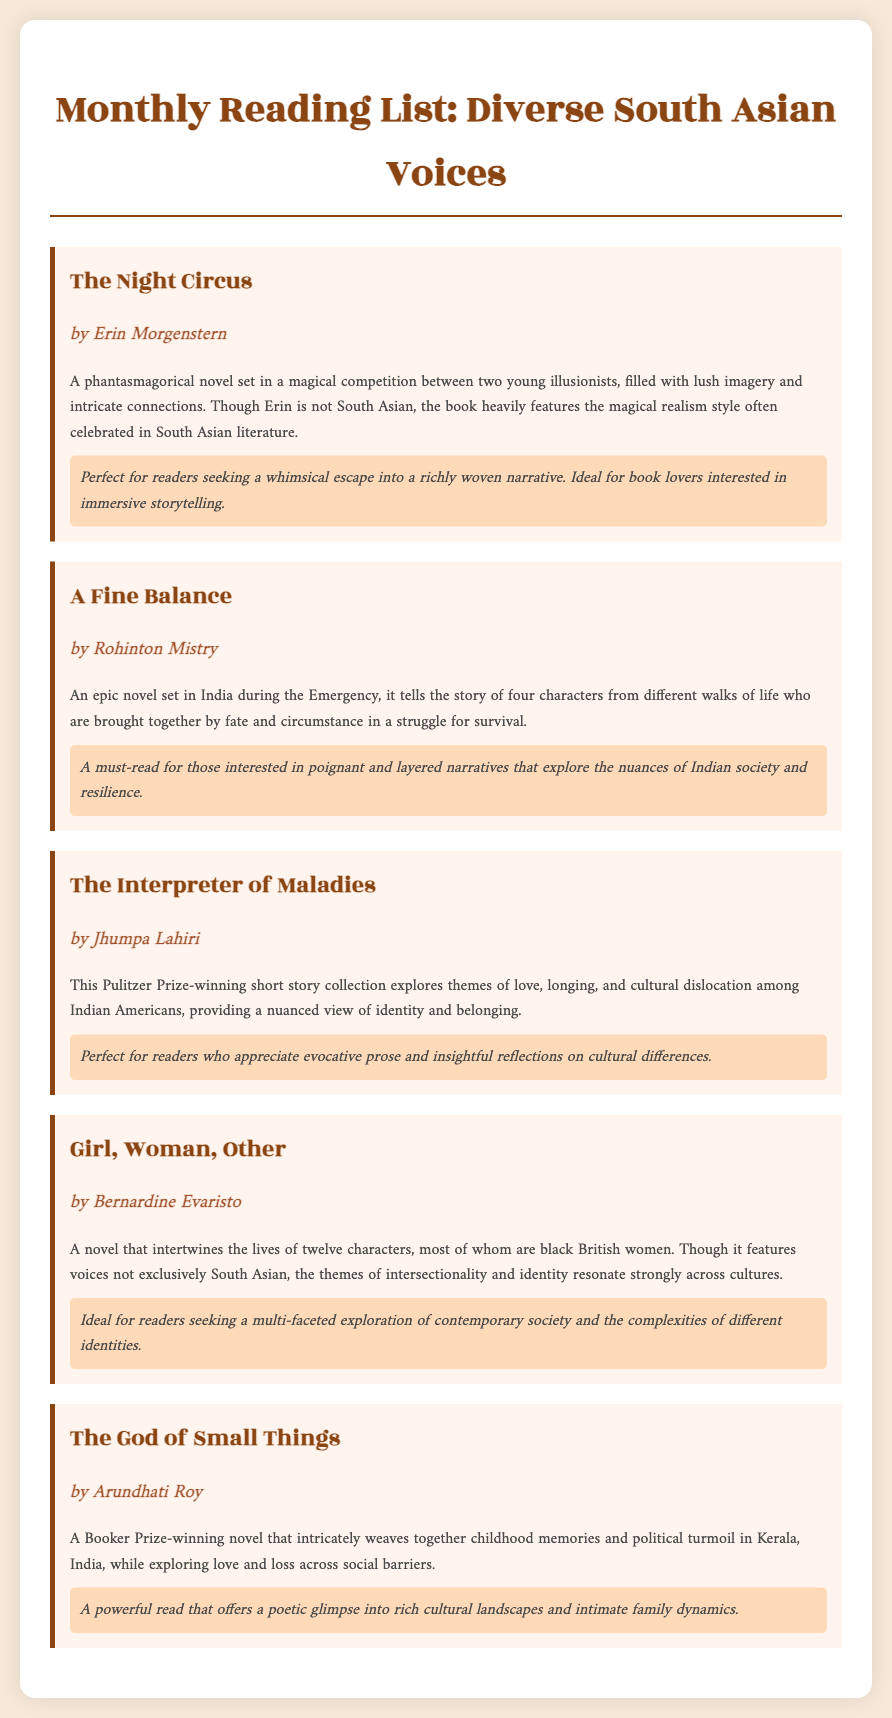what is the title of the first book listed? The first book listed in the document is The Night Circus.
Answer: The Night Circus who is the author of A Fine Balance? A Fine Balance is written by Rohinton Mistry.
Answer: Rohinton Mistry how many characters are primarily featured in A Fine Balance? A Fine Balance tells the story of four characters from different walks of life.
Answer: four which award did The Interpreter of Maladies win? The Interpreter of Maladies is a Pulitzer Prize-winning short story collection.
Answer: Pulitzer Prize what is a central theme explored in Girl, Woman, Other? The novel explores themes of intersectionality and identity.
Answer: intersectionality and identity which book is described as a powerful read? The God of Small Things is described as a powerful read.
Answer: The God of Small Things who is the author of the book that features themes of cultural dislocation? The book that explores themes of cultural dislocation is The Interpreter of Maladies by Jhumpa Lahiri.
Answer: Jhumpa Lahiri what type of narrative style is highlighted in The Night Circus? The Night Circus features a whimsical narrative style filled with lush imagery and intricate connections.
Answer: whimsical narrative style how does A Fine Balance explore Indian society? A Fine Balance explores the nuances of Indian society and resilience through its characters' struggles.
Answer: nuances of Indian society and resilience 